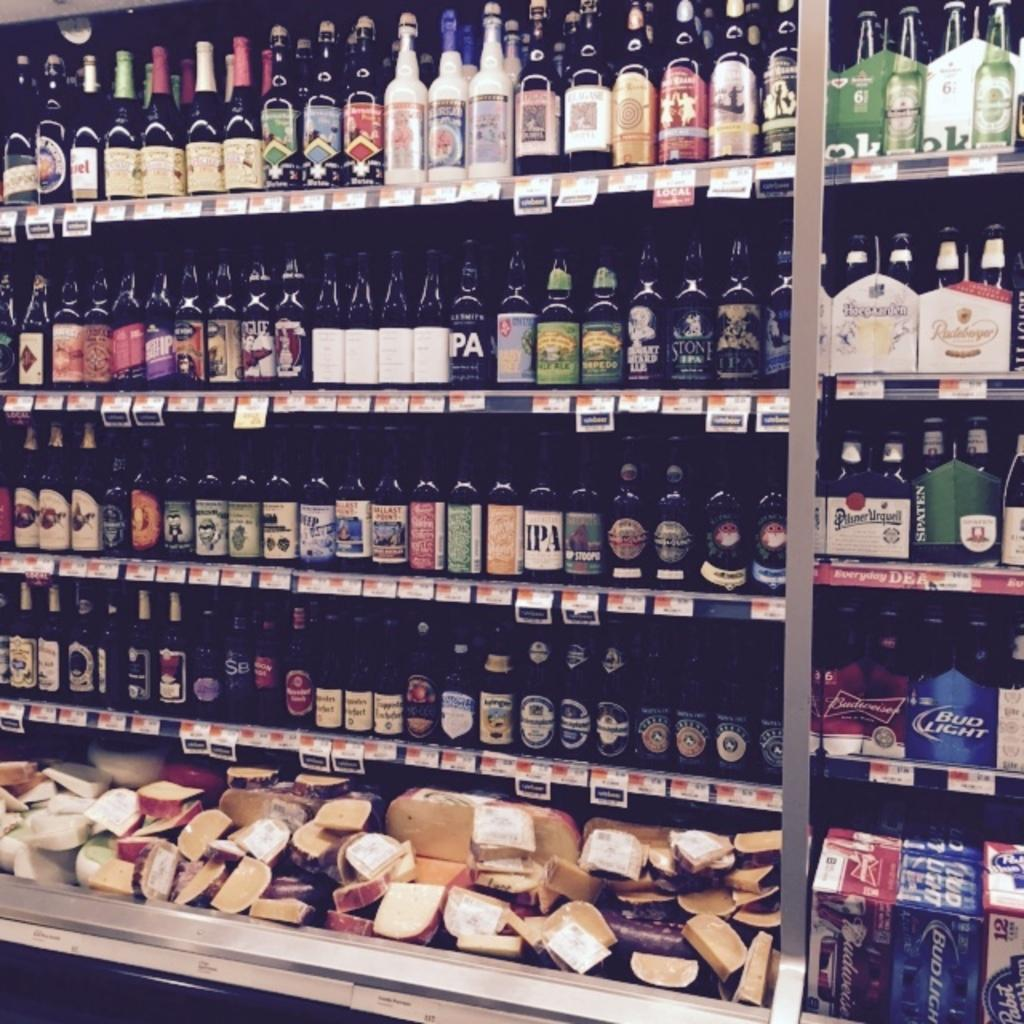<image>
Summarize the visual content of the image. a shelf full of bottles of IPA beers 